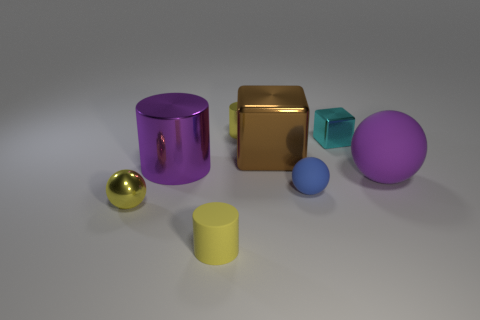There is a cyan shiny object that is the same size as the shiny ball; what shape is it?
Your answer should be compact. Cube. What number of objects are small metallic objects or purple objects that are behind the big purple sphere?
Provide a succinct answer. 4. Is the purple thing to the right of the blue rubber sphere made of the same material as the purple thing that is behind the big rubber sphere?
Your response must be concise. No. There is a rubber object that is the same color as the small metal ball; what shape is it?
Offer a very short reply. Cylinder. What number of purple objects are cylinders or cubes?
Make the answer very short. 1. What size is the blue ball?
Your answer should be compact. Small. Are there more matte things to the left of the small yellow rubber cylinder than big rubber cylinders?
Your answer should be compact. No. How many shiny things are behind the tiny cyan metallic object?
Ensure brevity in your answer.  1. Are there any rubber balls that have the same size as the purple cylinder?
Provide a succinct answer. Yes. The other metallic thing that is the same shape as the cyan shiny thing is what color?
Offer a terse response. Brown. 